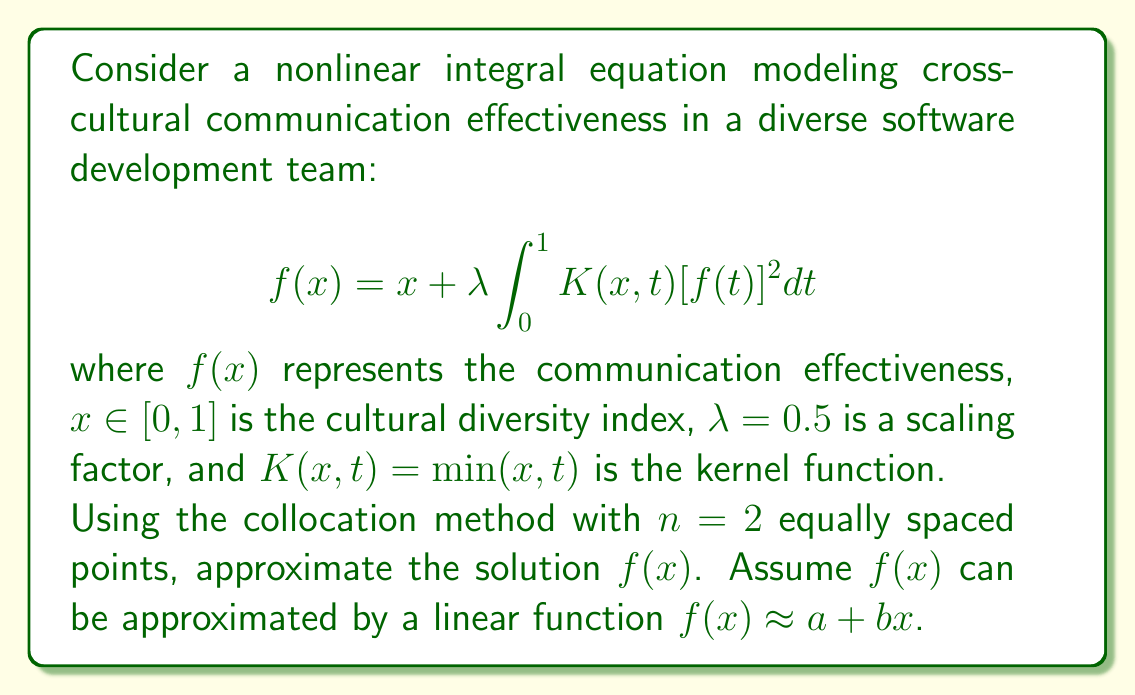Solve this math problem. To solve this problem, we'll follow these steps:

1) Choose collocation points: For $n=2$, we use $x_1 = 1/4$ and $x_2 = 3/4$.

2) Approximate $f(x)$ with a linear function: $f(x) \approx a + bx$

3) Substitute this into the integral equation at each collocation point:

   For $x_1 = 1/4$:
   $$a + \frac{1}{4}b = \frac{1}{4} + 0.5 \int_0^1 \min(\frac{1}{4},t) [a + bt]^2 dt$$

   For $x_2 = 3/4$:
   $$a + \frac{3}{4}b = \frac{3}{4} + 0.5 \int_0^1 \min(\frac{3}{4},t) [a + bt]^2 dt$$

4) Evaluate the integrals:

   For $x_1 = 1/4$:
   $$a + \frac{1}{4}b = \frac{1}{4} + 0.5 [\int_0^{1/4} t(a + bt)^2 dt + \int_{1/4}^1 \frac{1}{4}(a + bt)^2 dt]$$

   For $x_2 = 3/4$:
   $$a + \frac{3}{4}b = \frac{3}{4} + 0.5 [\int_0^{3/4} t(a + bt)^2 dt + \int_{3/4}^1 \frac{3}{4}(a + bt)^2 dt]$$

5) Solve these integrals and simplify:

   For $x_1 = 1/4$:
   $$a + \frac{1}{4}b = \frac{1}{4} + \frac{1}{384}(16a^3 + 24a^2b + 11ab^2 + 2b^3)$$

   For $x_2 = 3/4$:
   $$a + \frac{3}{4}b = \frac{3}{4} + \frac{1}{128}(48a^3 + 72a^2b + 33ab^2 + 5b^3)$$

6) These form a system of nonlinear equations. We can solve them numerically using a method like Newton-Raphson.

7) Using a numerical solver, we find the approximate solution:
   $a \approx 0.8858$ and $b \approx 0.1523$

Therefore, the approximate solution is $f(x) \approx 0.8858 + 0.1523x$.
Answer: $f(x) \approx 0.8858 + 0.1523x$ 